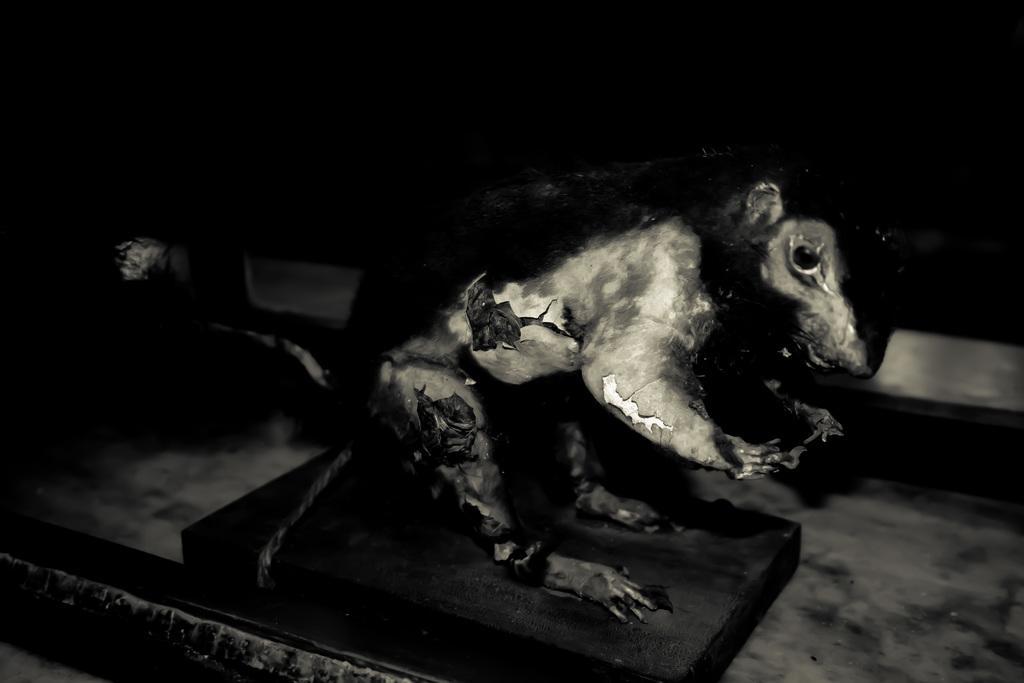In one or two sentences, can you explain what this image depicts? This is a black and white pic. In this image we can see the sculpture of an animal on a platform. In the background the image is dark. 